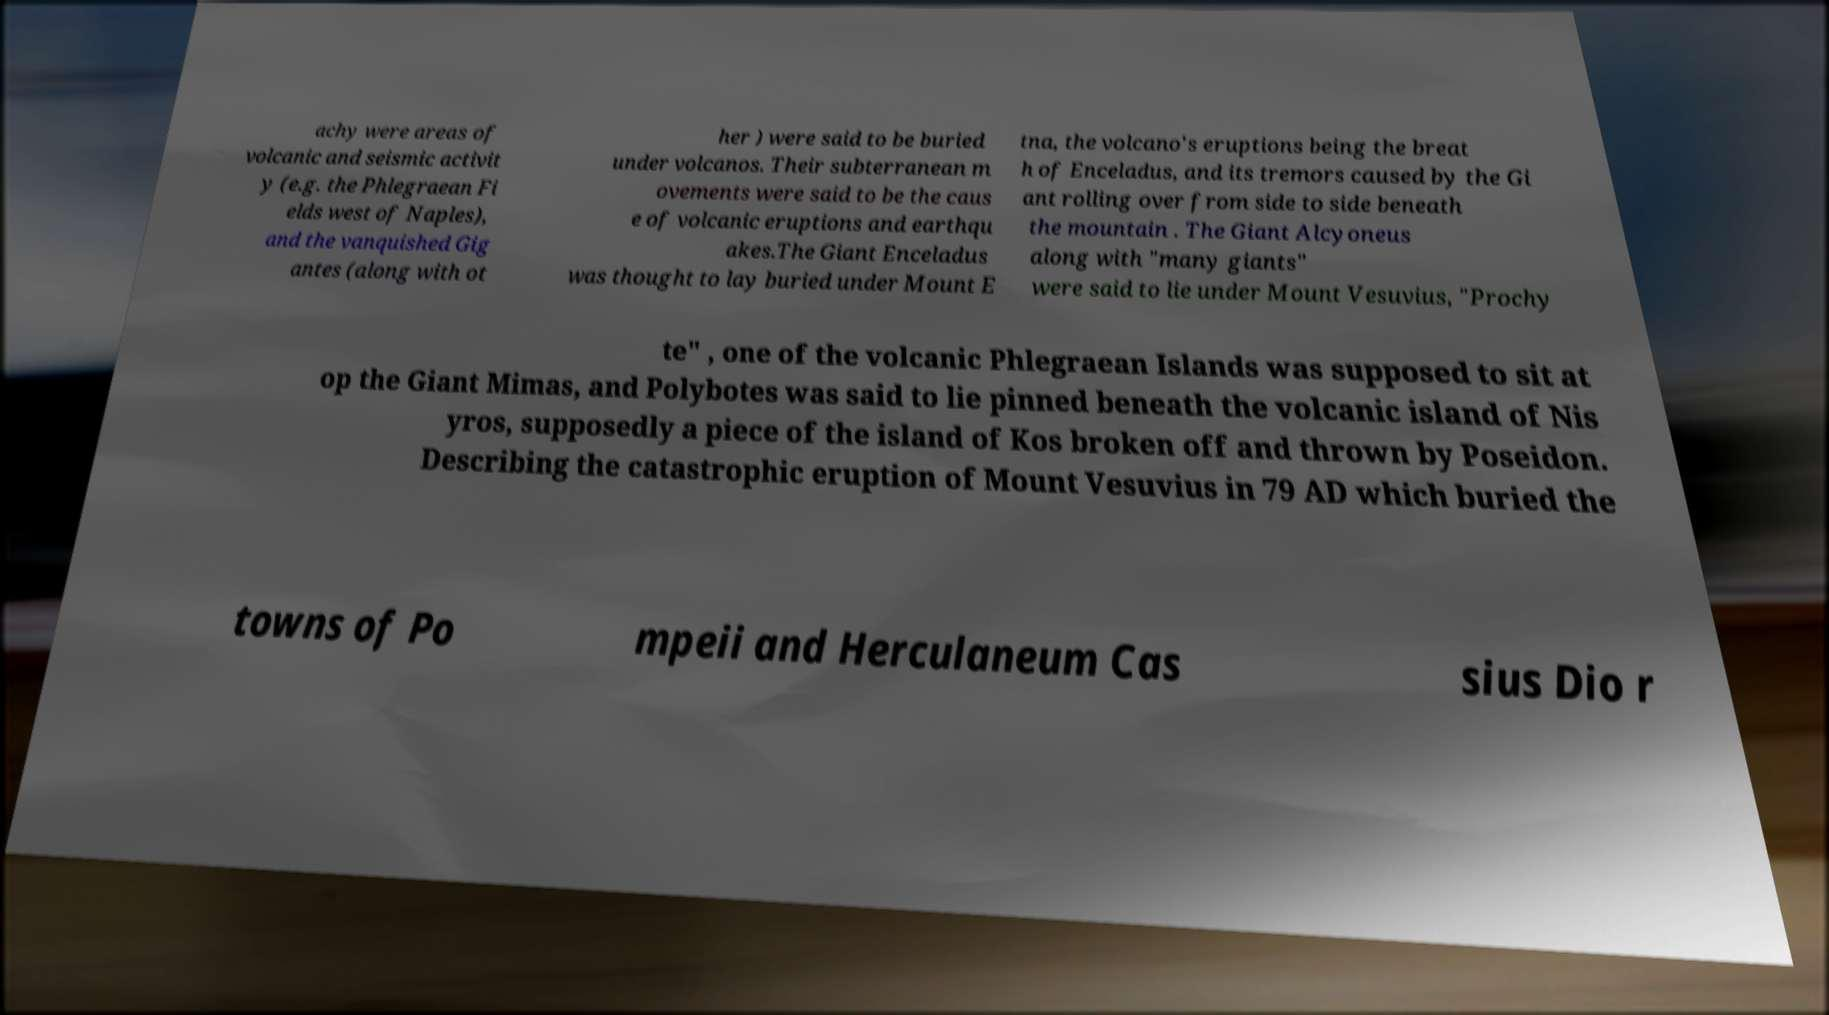Could you assist in decoding the text presented in this image and type it out clearly? achy were areas of volcanic and seismic activit y (e.g. the Phlegraean Fi elds west of Naples), and the vanquished Gig antes (along with ot her ) were said to be buried under volcanos. Their subterranean m ovements were said to be the caus e of volcanic eruptions and earthqu akes.The Giant Enceladus was thought to lay buried under Mount E tna, the volcano's eruptions being the breat h of Enceladus, and its tremors caused by the Gi ant rolling over from side to side beneath the mountain . The Giant Alcyoneus along with "many giants" were said to lie under Mount Vesuvius, "Prochy te" , one of the volcanic Phlegraean Islands was supposed to sit at op the Giant Mimas, and Polybotes was said to lie pinned beneath the volcanic island of Nis yros, supposedly a piece of the island of Kos broken off and thrown by Poseidon. Describing the catastrophic eruption of Mount Vesuvius in 79 AD which buried the towns of Po mpeii and Herculaneum Cas sius Dio r 